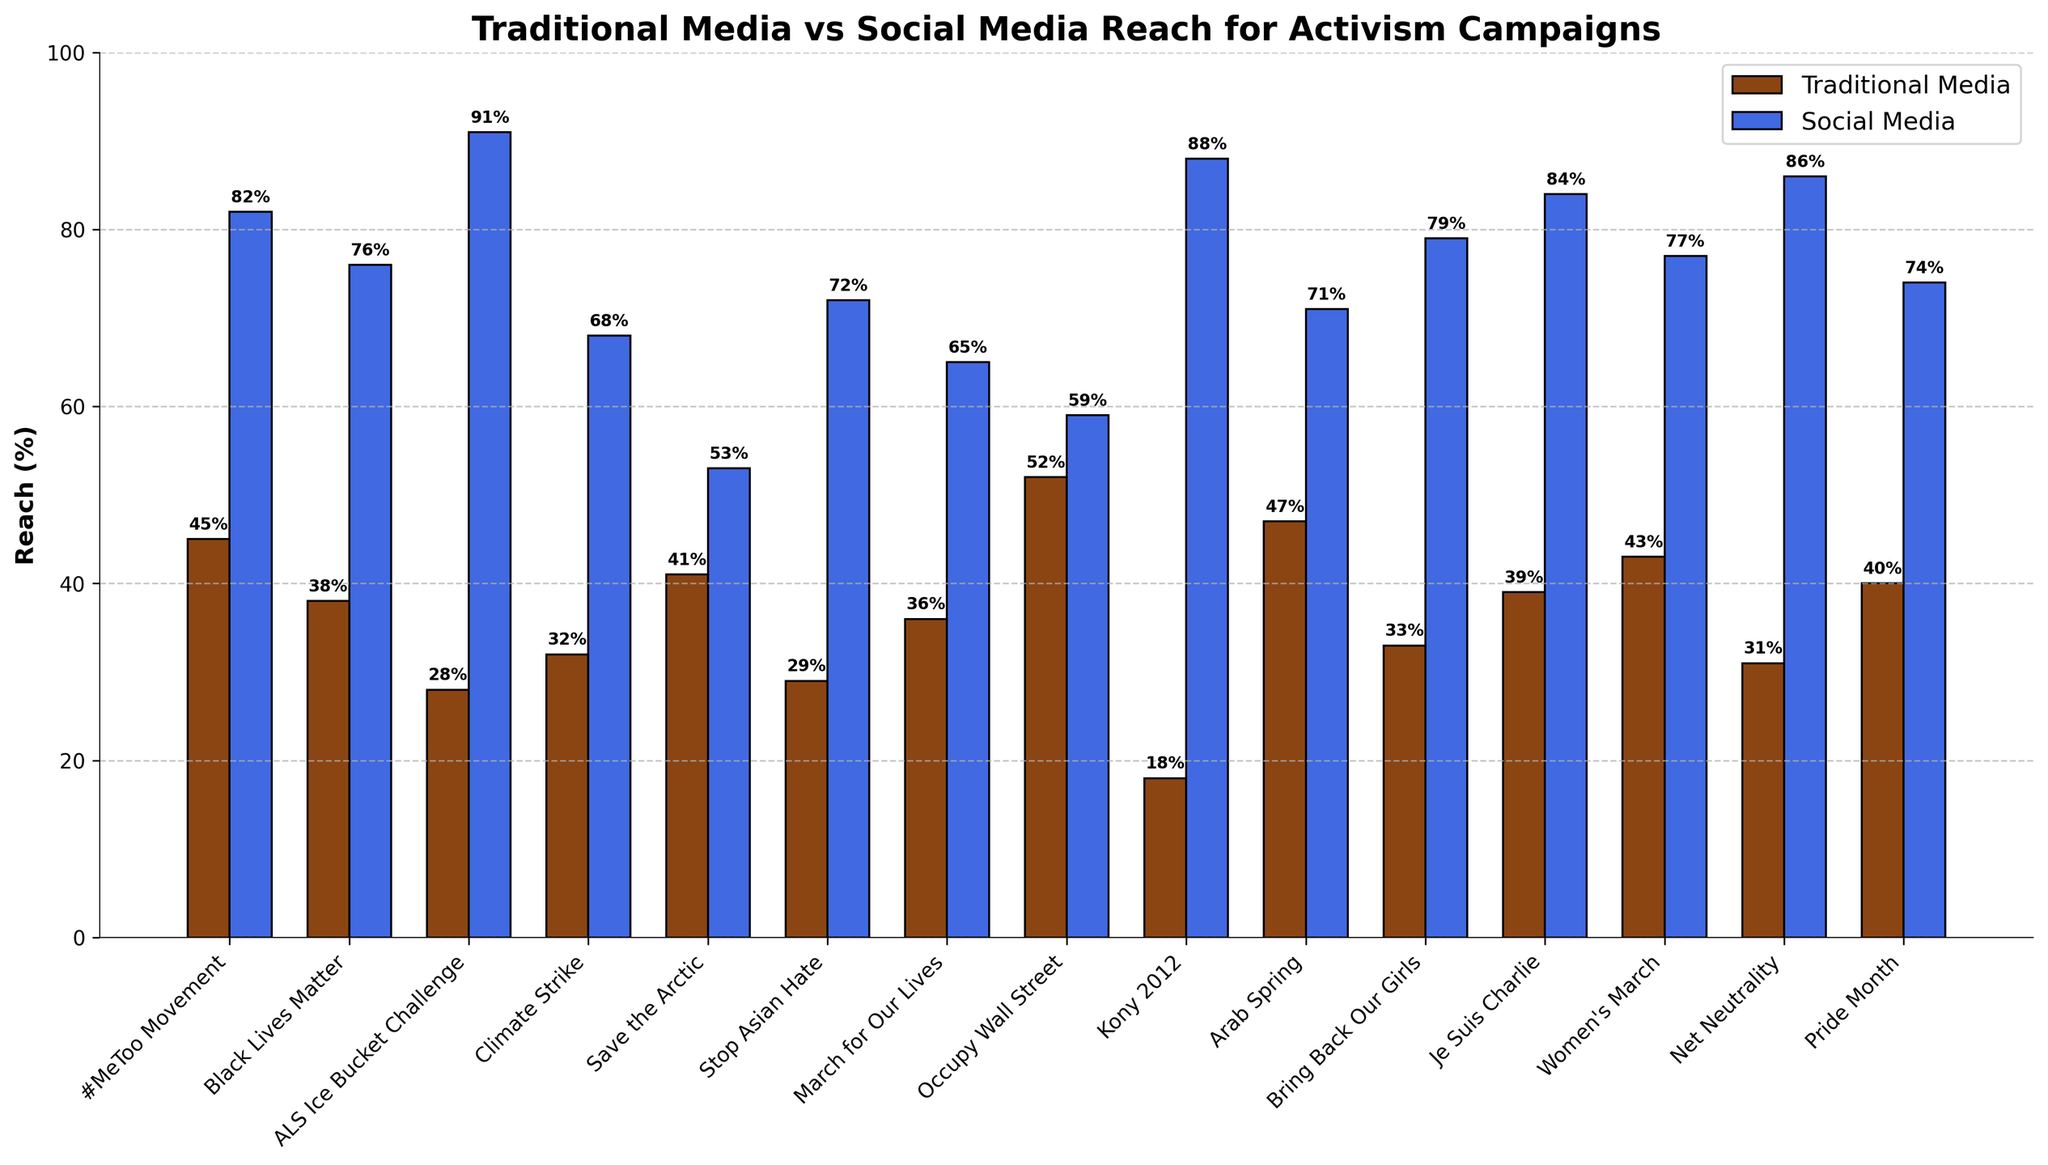What activism campaign has the highest reach via traditional media? Look at the heights of the bars representing traditional media reach, which are colored brown. The tallest bar indicates the highest reach.
Answer: Occupy Wall Street How much greater is the social media reach for the ALS Ice Bucket Challenge compared to its traditional media reach? Subtract the traditional media reach percentage from the social media reach percentage for the ALS Ice Bucket Challenge.
Answer: 63% Which campaign has a more balanced reach between traditional and social media? Compare the differences between the traditional and social media reach for each campaign by looking at the respective bars. The campaign with the smallest difference is the most balanced.
Answer: Save the Arctic Which campaign shows the largest difference in reach between traditional media and social media? Compare the differences between the traditional and social media reach for each campaign. The campaign with the largest absolute difference is the one with the largest difference.
Answer: ALS Ice Bucket Challenge Is there any campaign where traditional media reach is greater than social media reach? If so, which one? Look for any campaign where the brown bar (traditional media) is taller than the blue bar (social media).
Answer: Occupy Wall Street What's the average reach of the #MeToo Movement across both traditional and social media? Add the traditional media reach percentage and the social media reach percentage for the #MeToo Movement, then divide by 2.
Answer: 63.5% Compare the social media reach of the Arab Spring to that of March for Our Lives. Which one is higher? Look at the heights of the blue bars for both Arab Spring and March for Our Lives and identify which bar is taller.
Answer: Arab Spring Which campaign has the second-highest social media reach? First identify the highest social media reach, then find the next highest value by comparing the heights of the blue bars.
Answer: #MeToo Movement By what percentage does the social media reach of Black Lives Matter exceed that of its traditional media reach? Subtract the traditional media reach percentage from the social media reach percentage for Black Lives Matter, then state the difference.
Answer: 38% Which campaign has a higher traditional media reach: Pride Month or Je Suis Charlie? Compare the heights of the brown bars for Pride Month and Je Suis Charlie and identify which one is taller.
Answer: Je Suis Charlie 